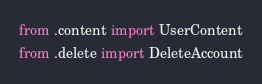<code> <loc_0><loc_0><loc_500><loc_500><_Python_>from .content import UserContent
from .delete import DeleteAccount
</code> 